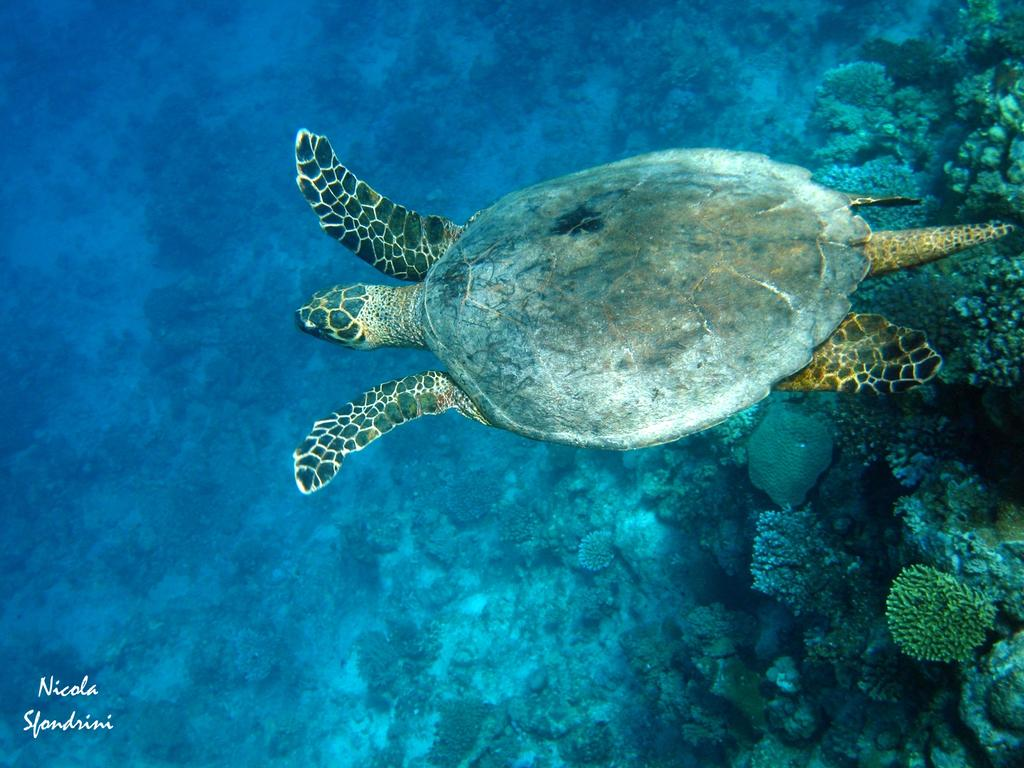What animal is in the water in the image? There is a tortoise in the water in the image. What else can be seen under the water? There are plants under the water in the image. What is on the left side of the image? There is some text on the left side of the image. How many cakes are being ridden by the tortoise in the image? There are no cakes or bikes present in the image, and the tortoise is not riding anything. 